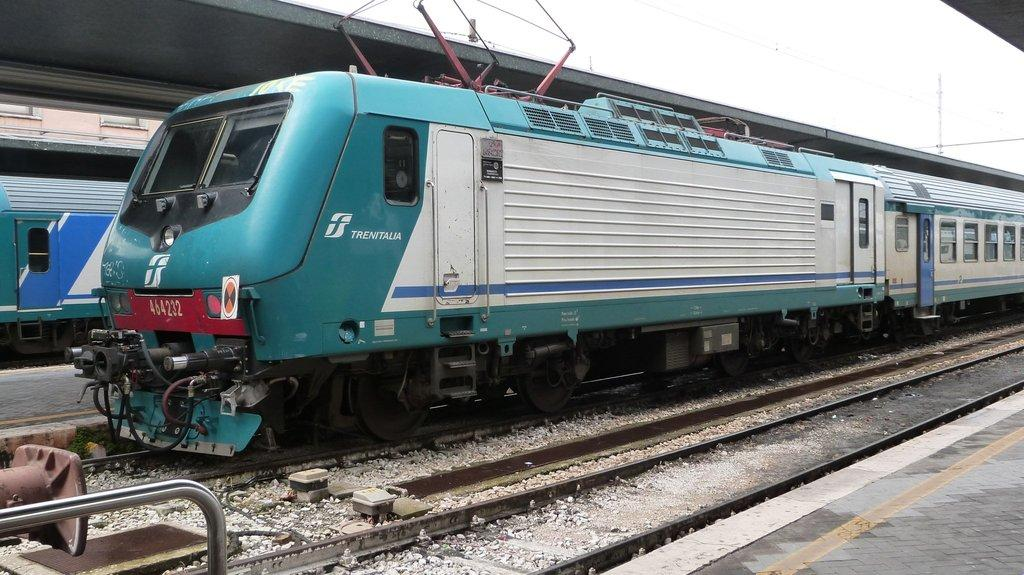<image>
Create a compact narrative representing the image presented. A turquoise train with the number 464232 written on the front 